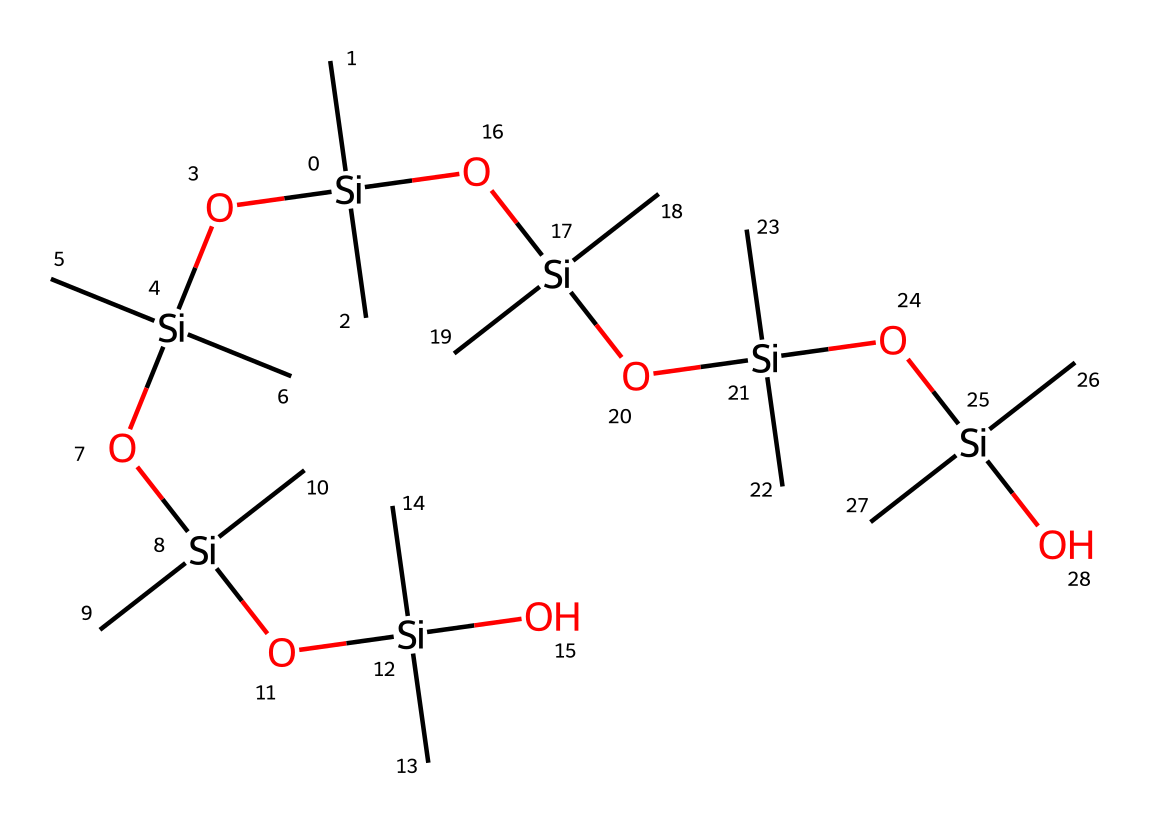What is the central atom in this chemical structure? The central atom in this structure is silicon, as it is surrounded by carbon and oxygen atoms. The silicon atoms are indicated by the presence of "Si" in the SMILES representation.
Answer: silicon How many silicon atoms are present in this compound? By analyzing the SMILES representation, we can count the occurrences of "Si," which indicates there are six silicon atoms in total within the structure.
Answer: six What functional groups are present in this molecule? The molecule contains hydroxyl (-OH) groups as indicated by the "O" in the chemical makeup, which suggests the presence of silanol functionalities due to the combination of silicon and oxygen atoms.
Answer: hydroxyl groups Which part of this chemical contributes to its elastic properties? The long siloxane chains made from repeated silicon-oxygen linkages, as seen in the structure, contribute to the elasticity characteristic of silicone elastomers.
Answer: siloxane chains How does the number of carbon atoms compare to silicon atoms in this compound? Counting the "C" atoms present within the SMILES representation shows that there are a total of 12 carbon atoms, while there are 6 silicon atoms. Thus, there are twice as many carbon atoms compared to silicon atoms.
Answer: twelve What type of silicone elastomer is represented by this chemical structure? This structure represents a poly(dimethylsiloxane) (PDMS), which is characterized by the alternating silicon and oxygen atoms linked with methyl groups as indicated in the structure.
Answer: poly(dimethylsiloxane) Are there any branches in the carbon chain of this compound? The SMILES representation indicates that the carbon atoms are primarily in a branched configuration due to the methyl groups attached to several silicon atoms, showing branching in the molecular structure.
Answer: yes 